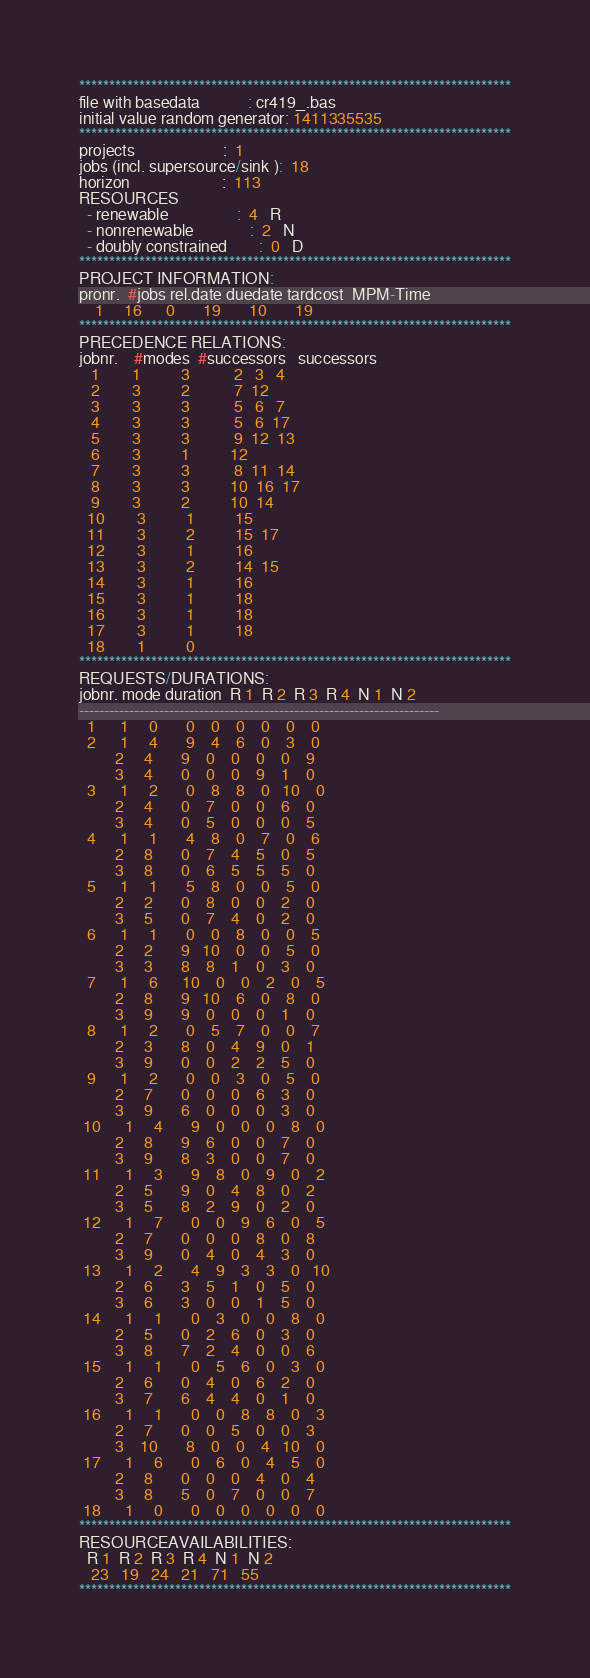<code> <loc_0><loc_0><loc_500><loc_500><_ObjectiveC_>************************************************************************
file with basedata            : cr419_.bas
initial value random generator: 1411335535
************************************************************************
projects                      :  1
jobs (incl. supersource/sink ):  18
horizon                       :  113
RESOURCES
  - renewable                 :  4   R
  - nonrenewable              :  2   N
  - doubly constrained        :  0   D
************************************************************************
PROJECT INFORMATION:
pronr.  #jobs rel.date duedate tardcost  MPM-Time
    1     16      0       19       10       19
************************************************************************
PRECEDENCE RELATIONS:
jobnr.    #modes  #successors   successors
   1        1          3           2   3   4
   2        3          2           7  12
   3        3          3           5   6   7
   4        3          3           5   6  17
   5        3          3           9  12  13
   6        3          1          12
   7        3          3           8  11  14
   8        3          3          10  16  17
   9        3          2          10  14
  10        3          1          15
  11        3          2          15  17
  12        3          1          16
  13        3          2          14  15
  14        3          1          16
  15        3          1          18
  16        3          1          18
  17        3          1          18
  18        1          0        
************************************************************************
REQUESTS/DURATIONS:
jobnr. mode duration  R 1  R 2  R 3  R 4  N 1  N 2
------------------------------------------------------------------------
  1      1     0       0    0    0    0    0    0
  2      1     4       9    4    6    0    3    0
         2     4       9    0    0    0    0    9
         3     4       0    0    0    9    1    0
  3      1     2       0    8    8    0   10    0
         2     4       0    7    0    0    6    0
         3     4       0    5    0    0    0    5
  4      1     1       4    8    0    7    0    6
         2     8       0    7    4    5    0    5
         3     8       0    6    5    5    5    0
  5      1     1       5    8    0    0    5    0
         2     2       0    8    0    0    2    0
         3     5       0    7    4    0    2    0
  6      1     1       0    0    8    0    0    5
         2     2       9   10    0    0    5    0
         3     3       8    8    1    0    3    0
  7      1     6      10    0    0    2    0    5
         2     8       9   10    6    0    8    0
         3     9       9    0    0    0    1    0
  8      1     2       0    5    7    0    0    7
         2     3       8    0    4    9    0    1
         3     9       0    0    2    2    5    0
  9      1     2       0    0    3    0    5    0
         2     7       0    0    0    6    3    0
         3     9       6    0    0    0    3    0
 10      1     4       9    0    0    0    8    0
         2     8       9    6    0    0    7    0
         3     9       8    3    0    0    7    0
 11      1     3       9    8    0    9    0    2
         2     5       9    0    4    8    0    2
         3     5       8    2    9    0    2    0
 12      1     7       0    0    9    6    0    5
         2     7       0    0    0    8    0    8
         3     9       0    4    0    4    3    0
 13      1     2       4    9    3    3    0   10
         2     6       3    5    1    0    5    0
         3     6       3    0    0    1    5    0
 14      1     1       0    3    0    0    8    0
         2     5       0    2    6    0    3    0
         3     8       7    2    4    0    0    6
 15      1     1       0    5    6    0    3    0
         2     6       0    4    0    6    2    0
         3     7       6    4    4    0    1    0
 16      1     1       0    0    8    8    0    3
         2     7       0    0    5    0    0    3
         3    10       8    0    0    4   10    0
 17      1     6       0    6    0    4    5    0
         2     8       0    0    0    4    0    4
         3     8       5    0    7    0    0    7
 18      1     0       0    0    0    0    0    0
************************************************************************
RESOURCEAVAILABILITIES:
  R 1  R 2  R 3  R 4  N 1  N 2
   23   19   24   21   71   55
************************************************************************
</code> 